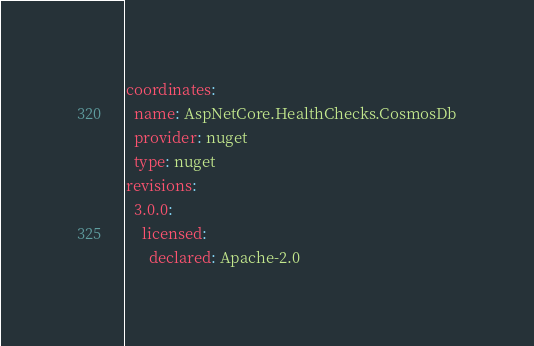<code> <loc_0><loc_0><loc_500><loc_500><_YAML_>coordinates:
  name: AspNetCore.HealthChecks.CosmosDb
  provider: nuget
  type: nuget
revisions:
  3.0.0:
    licensed:
      declared: Apache-2.0
</code> 